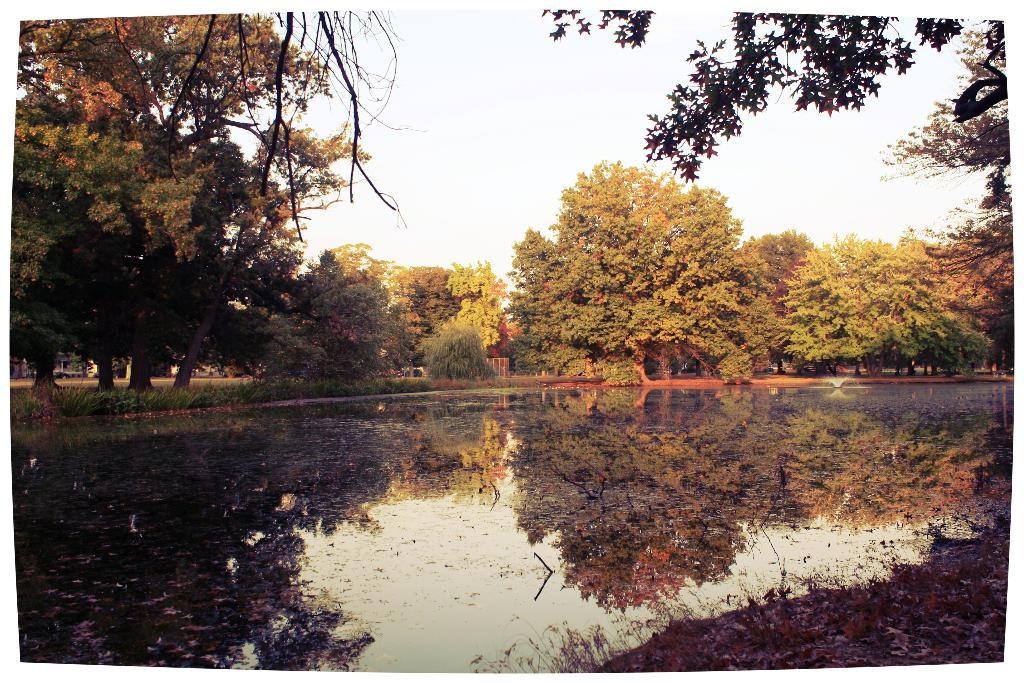What is present at the bottom of the image? There is water at the bottom of the image. What type of vegetation can be seen in the image? There are trees, plants, and grass in the image. What part of the natural environment is visible in the image? The sky is visible in the image. Can you tell me which actor is holding the jar in the image? There is no actor or jar present in the image. What type of amusement can be seen in the image? There is no amusement depicted in the image; it features natural elements such as water, trees, plants, grass, and the sky. 